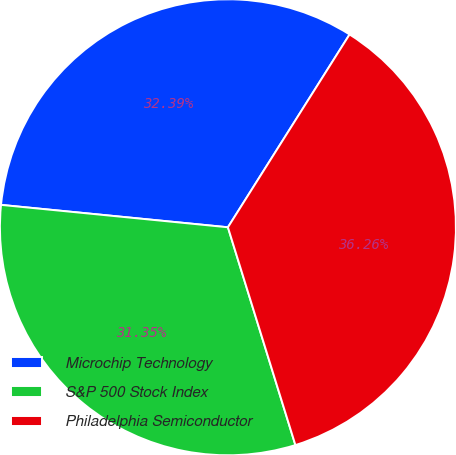Convert chart to OTSL. <chart><loc_0><loc_0><loc_500><loc_500><pie_chart><fcel>Microchip Technology<fcel>S&P 500 Stock Index<fcel>Philadelphia Semiconductor<nl><fcel>32.39%<fcel>31.35%<fcel>36.26%<nl></chart> 